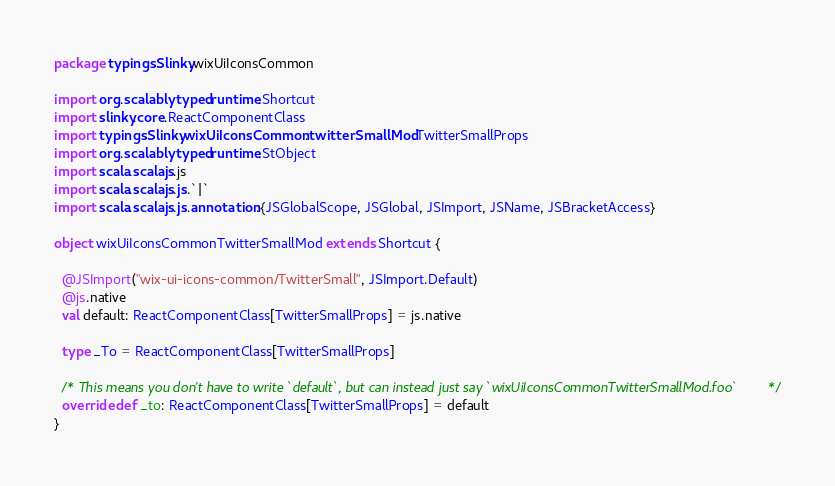Convert code to text. <code><loc_0><loc_0><loc_500><loc_500><_Scala_>package typingsSlinky.wixUiIconsCommon

import org.scalablytyped.runtime.Shortcut
import slinky.core.ReactComponentClass
import typingsSlinky.wixUiIconsCommon.twitterSmallMod.TwitterSmallProps
import org.scalablytyped.runtime.StObject
import scala.scalajs.js
import scala.scalajs.js.`|`
import scala.scalajs.js.annotation.{JSGlobalScope, JSGlobal, JSImport, JSName, JSBracketAccess}

object wixUiIconsCommonTwitterSmallMod extends Shortcut {
  
  @JSImport("wix-ui-icons-common/TwitterSmall", JSImport.Default)
  @js.native
  val default: ReactComponentClass[TwitterSmallProps] = js.native
  
  type _To = ReactComponentClass[TwitterSmallProps]
  
  /* This means you don't have to write `default`, but can instead just say `wixUiIconsCommonTwitterSmallMod.foo` */
  override def _to: ReactComponentClass[TwitterSmallProps] = default
}
</code> 